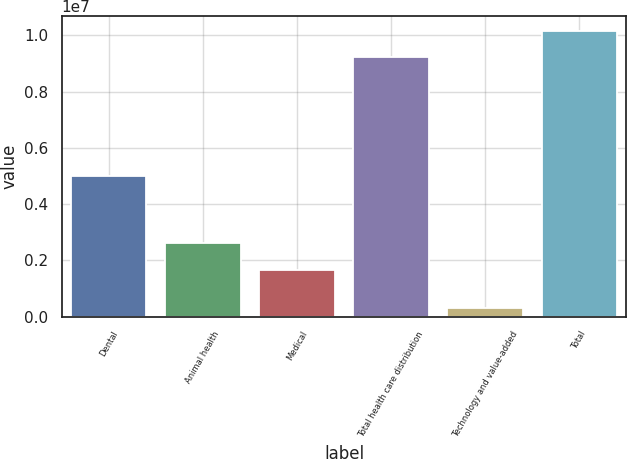Convert chart. <chart><loc_0><loc_0><loc_500><loc_500><bar_chart><fcel>Dental<fcel>Animal health<fcel>Medical<fcel>Total health care distribution<fcel>Technology and value-added<fcel>Total<nl><fcel>4.99797e+06<fcel>2.59946e+06<fcel>1.64317e+06<fcel>9.2406e+06<fcel>320047<fcel>1.01647e+07<nl></chart> 